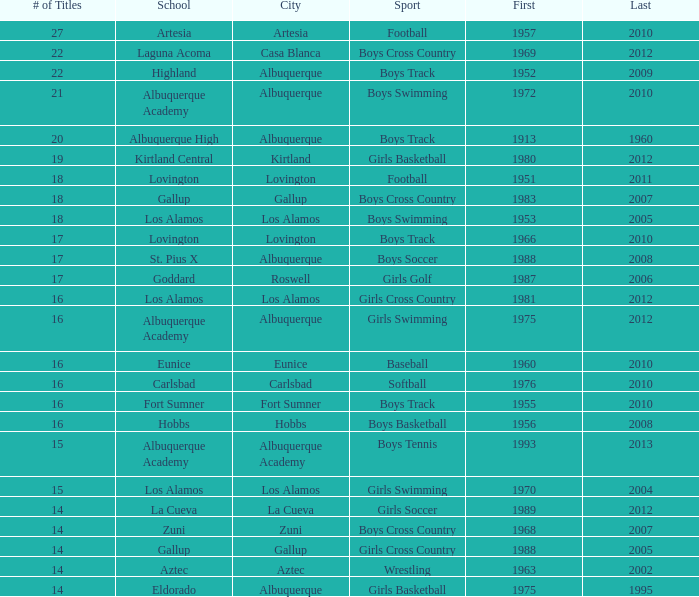In what city is the school possessing under 17 boys basketball trophies, with the final championship taking place after 2005? Hobbs. 